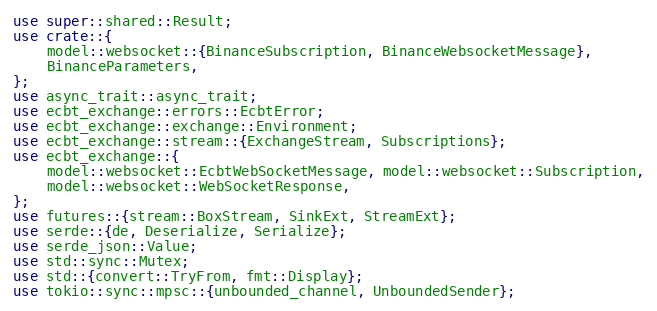<code> <loc_0><loc_0><loc_500><loc_500><_Rust_>use super::shared::Result;
use crate::{
    model::websocket::{BinanceSubscription, BinanceWebsocketMessage},
    BinanceParameters,
};
use async_trait::async_trait;
use ecbt_exchange::errors::EcbtError;
use ecbt_exchange::exchange::Environment;
use ecbt_exchange::stream::{ExchangeStream, Subscriptions};
use ecbt_exchange::{
    model::websocket::EcbtWebSocketMessage, model::websocket::Subscription,
    model::websocket::WebSocketResponse,
};
use futures::{stream::BoxStream, SinkExt, StreamExt};
use serde::{de, Deserialize, Serialize};
use serde_json::Value;
use std::sync::Mutex;
use std::{convert::TryFrom, fmt::Display};
use tokio::sync::mpsc::{unbounded_channel, UnboundedSender};</code> 